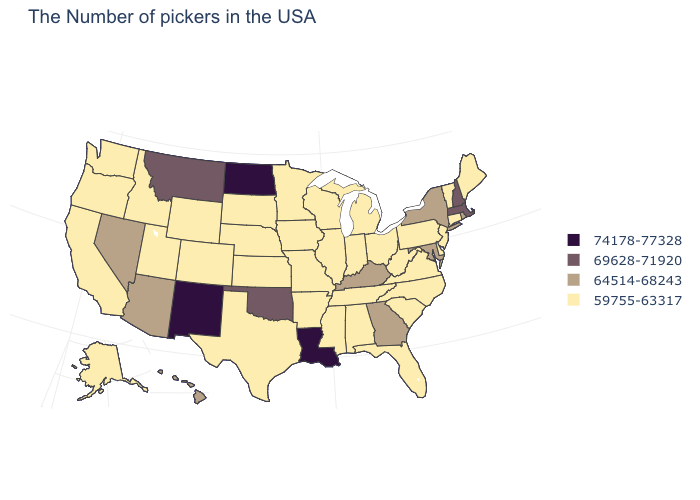What is the highest value in the MidWest ?
Keep it brief. 74178-77328. Is the legend a continuous bar?
Short answer required. No. Among the states that border Massachusetts , which have the lowest value?
Keep it brief. Vermont, Connecticut. Does Hawaii have the lowest value in the USA?
Quick response, please. No. Does Tennessee have the lowest value in the USA?
Answer briefly. Yes. Name the states that have a value in the range 74178-77328?
Keep it brief. Louisiana, North Dakota, New Mexico. What is the highest value in the USA?
Concise answer only. 74178-77328. Name the states that have a value in the range 74178-77328?
Answer briefly. Louisiana, North Dakota, New Mexico. Name the states that have a value in the range 69628-71920?
Be succinct. Massachusetts, New Hampshire, Oklahoma, Montana. What is the value of Virginia?
Short answer required. 59755-63317. Which states have the lowest value in the USA?
Be succinct. Maine, Vermont, Connecticut, New Jersey, Delaware, Pennsylvania, Virginia, North Carolina, South Carolina, West Virginia, Ohio, Florida, Michigan, Indiana, Alabama, Tennessee, Wisconsin, Illinois, Mississippi, Missouri, Arkansas, Minnesota, Iowa, Kansas, Nebraska, Texas, South Dakota, Wyoming, Colorado, Utah, Idaho, California, Washington, Oregon, Alaska. What is the lowest value in states that border Oregon?
Keep it brief. 59755-63317. Which states hav the highest value in the MidWest?
Quick response, please. North Dakota. Among the states that border West Virginia , does Kentucky have the lowest value?
Keep it brief. No. What is the value of Alabama?
Answer briefly. 59755-63317. 